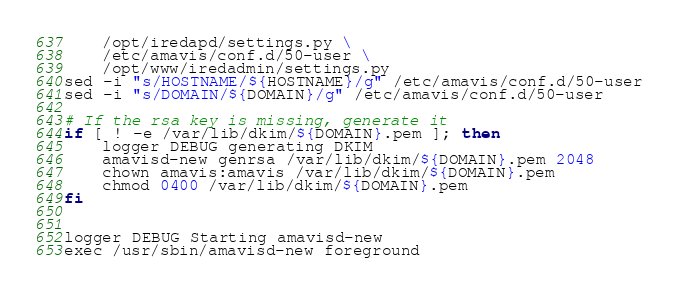<code> <loc_0><loc_0><loc_500><loc_500><_Bash_>    /opt/iredapd/settings.py \
    /etc/amavis/conf.d/50-user \
    /opt/www/iredadmin/settings.py
sed -i "s/HOSTNAME/${HOSTNAME}/g" /etc/amavis/conf.d/50-user
sed -i "s/DOMAIN/${DOMAIN}/g" /etc/amavis/conf.d/50-user

# If the rsa key is missing, generate it
if [ ! -e /var/lib/dkim/${DOMAIN}.pem ]; then
    logger DEBUG generating DKIM
    amavisd-new genrsa /var/lib/dkim/${DOMAIN}.pem 2048
    chown amavis:amavis /var/lib/dkim/${DOMAIN}.pem
    chmod 0400 /var/lib/dkim/${DOMAIN}.pem
fi


logger DEBUG Starting amavisd-new
exec /usr/sbin/amavisd-new foreground
</code> 